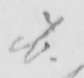Can you read and transcribe this handwriting? ib . 